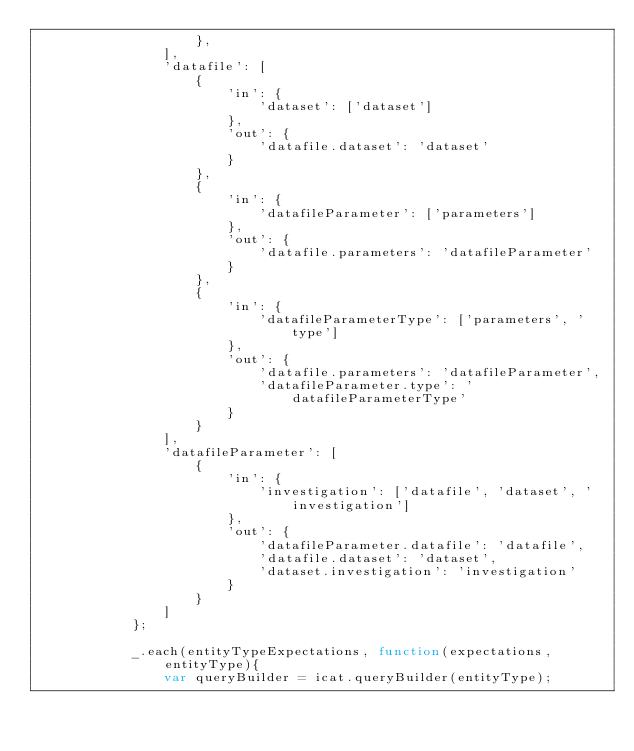<code> <loc_0><loc_0><loc_500><loc_500><_JavaScript_>                    },
                ],
                'datafile': [
                    {
                        'in': {
                            'dataset': ['dataset']
                        },
                        'out': {
                            'datafile.dataset': 'dataset'
                        }
                    },
                    {
                        'in': {
                            'datafileParameter': ['parameters']
                        },
                        'out': {
                            'datafile.parameters': 'datafileParameter'
                        }
                    },
                    {
                        'in': {
                            'datafileParameterType': ['parameters', 'type']
                        },
                        'out': {
                            'datafile.parameters': 'datafileParameter',
                            'datafileParameter.type': 'datafileParameterType'
                        }
                    }
                ],
                'datafileParameter': [
                    {
                        'in': {
                            'investigation': ['datafile', 'dataset', 'investigation']
                        },
                        'out': {
                            'datafileParameter.datafile': 'datafile',
                            'datafile.dataset': 'dataset',
                            'dataset.investigation': 'investigation'
                        }
                    }
                ]
            };

            _.each(entityTypeExpectations, function(expectations, entityType){
                var queryBuilder = icat.queryBuilder(entityType);</code> 